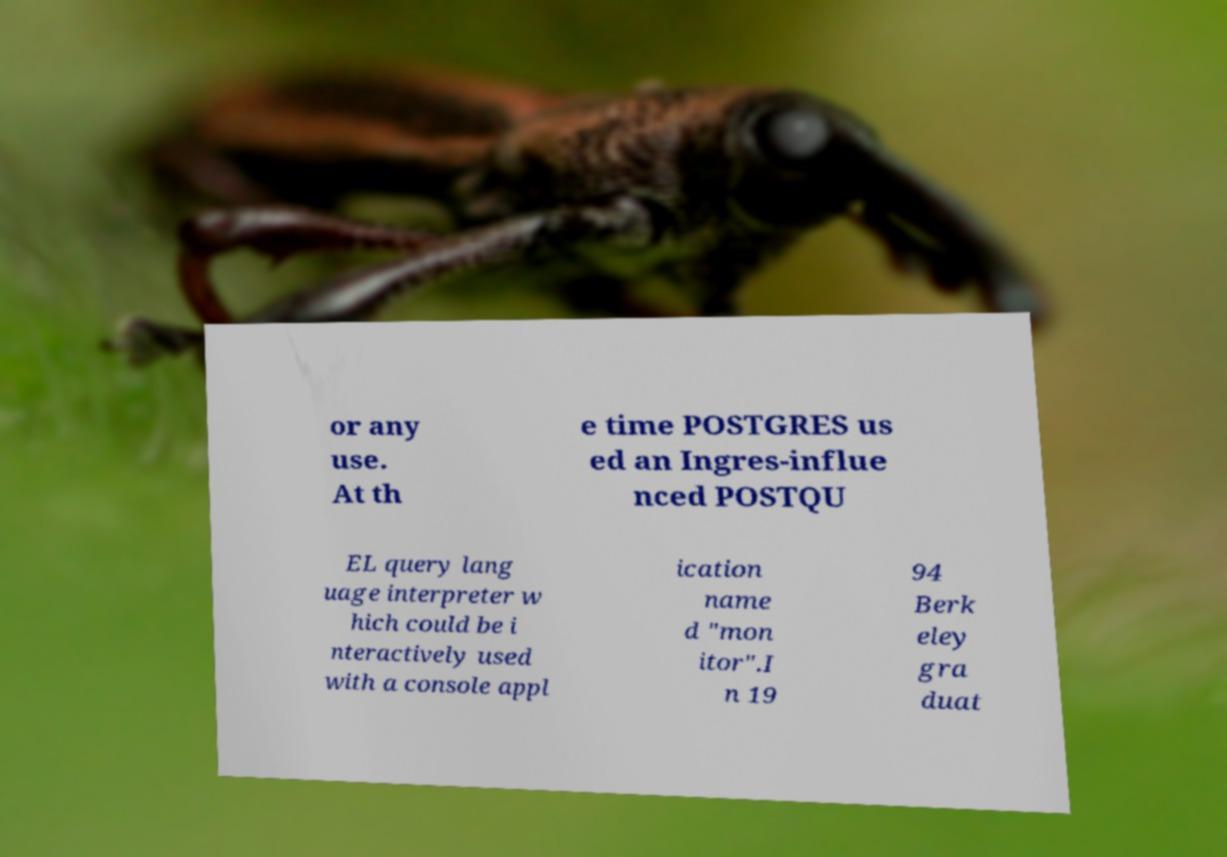Please read and relay the text visible in this image. What does it say? or any use. At th e time POSTGRES us ed an Ingres-influe nced POSTQU EL query lang uage interpreter w hich could be i nteractively used with a console appl ication name d "mon itor".I n 19 94 Berk eley gra duat 